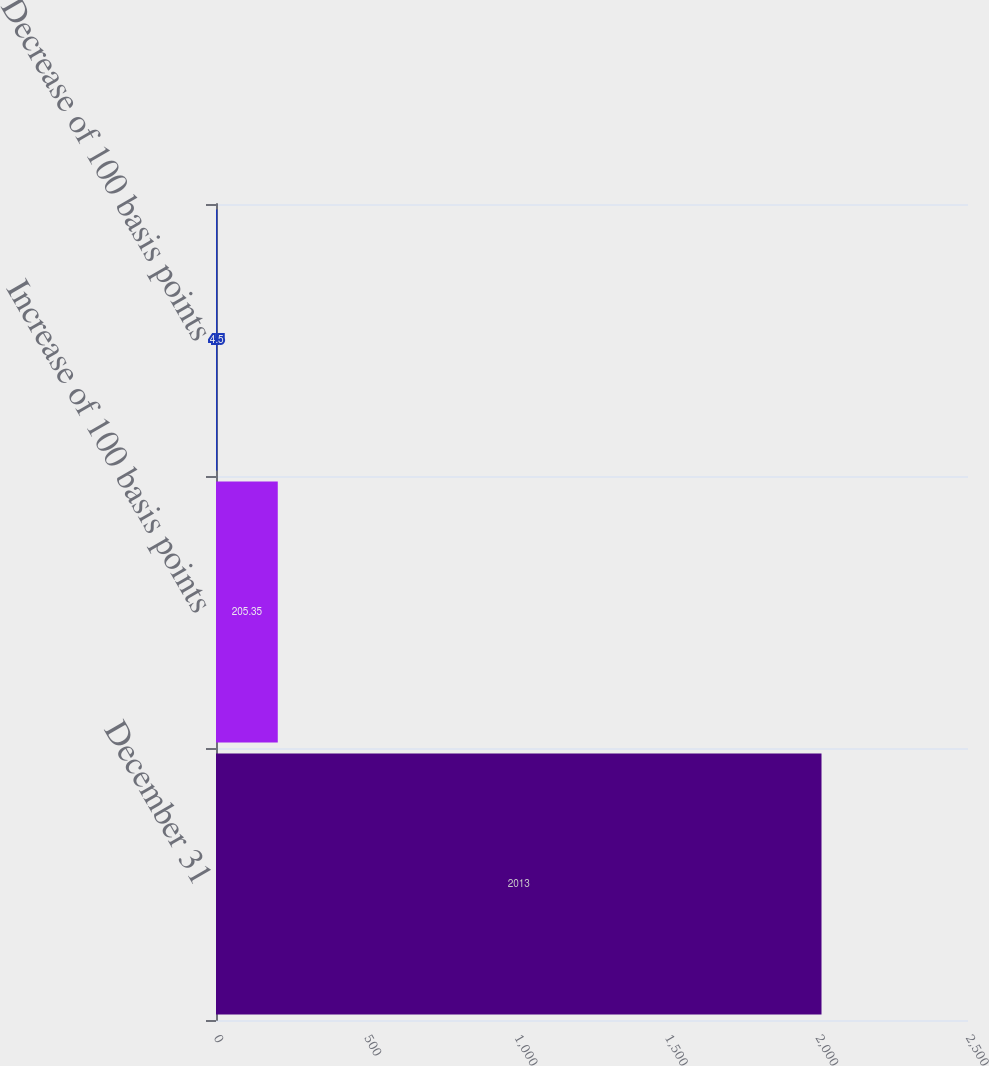Convert chart. <chart><loc_0><loc_0><loc_500><loc_500><bar_chart><fcel>December 31<fcel>Increase of 100 basis points<fcel>Decrease of 100 basis points<nl><fcel>2013<fcel>205.35<fcel>4.5<nl></chart> 